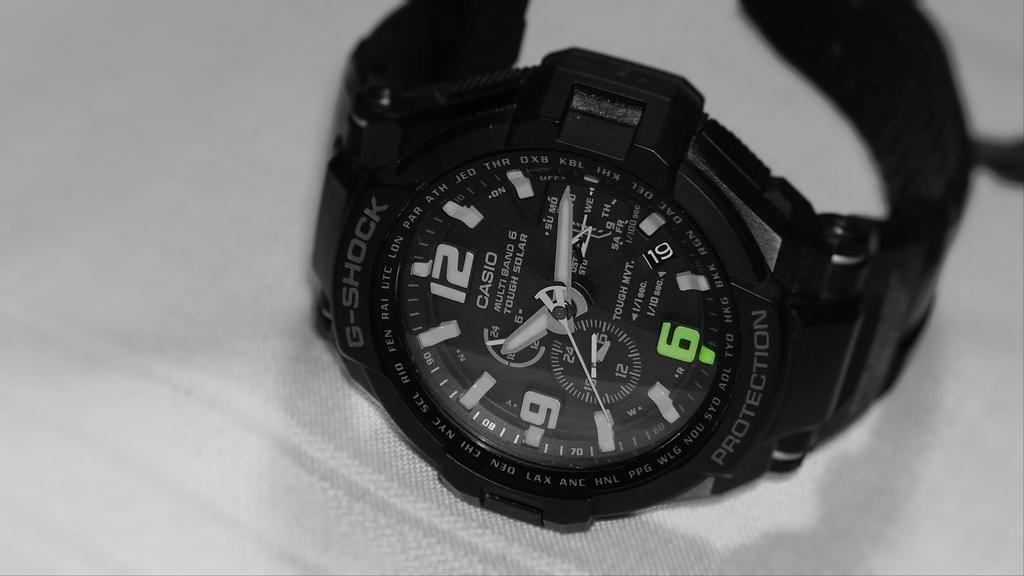Provide a one-sentence caption for the provided image. A black G-shock watch sits on its side telling us it is a quarter past ten. 